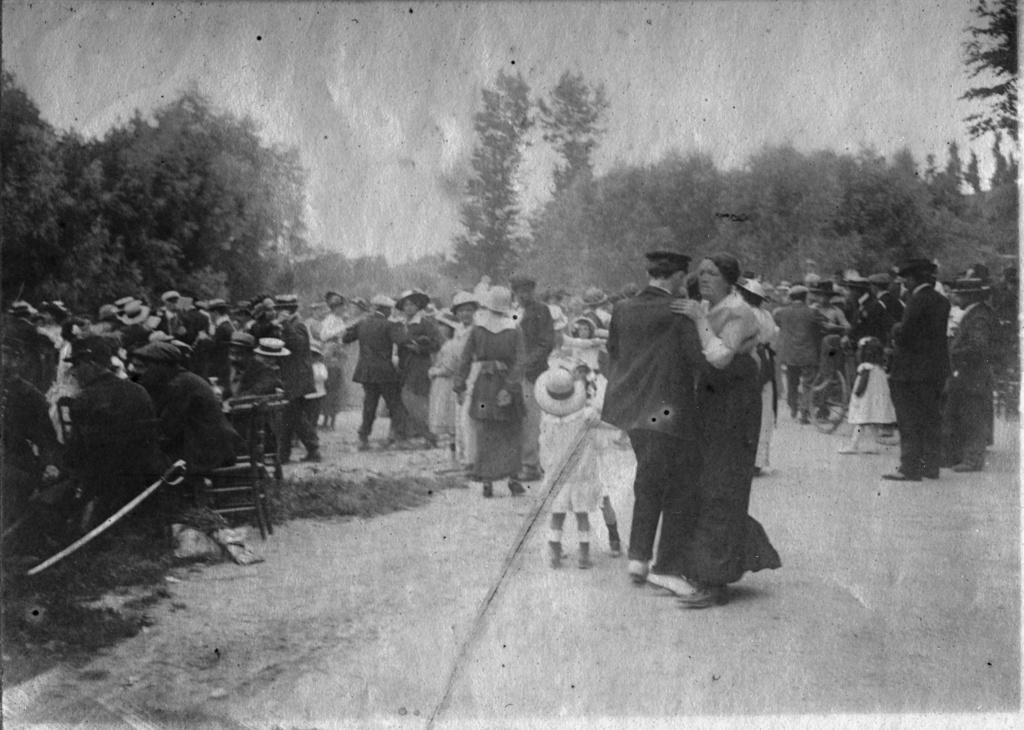How many people are in the image? There is a group of people in the image. What are the people in the image doing? The people are standing. What object can be seen in the image that is typically used for cutting? There is a knife visible in the image. What type of natural scenery is visible in the background of the image? There are trees in the background of the image. What is the color scheme of the image? The image is in black and white. How many sisters are shaking hands in the image? There are no sisters or handshakes present in the image. What type of seat can be seen in the image? There is no seat visible in the image. 